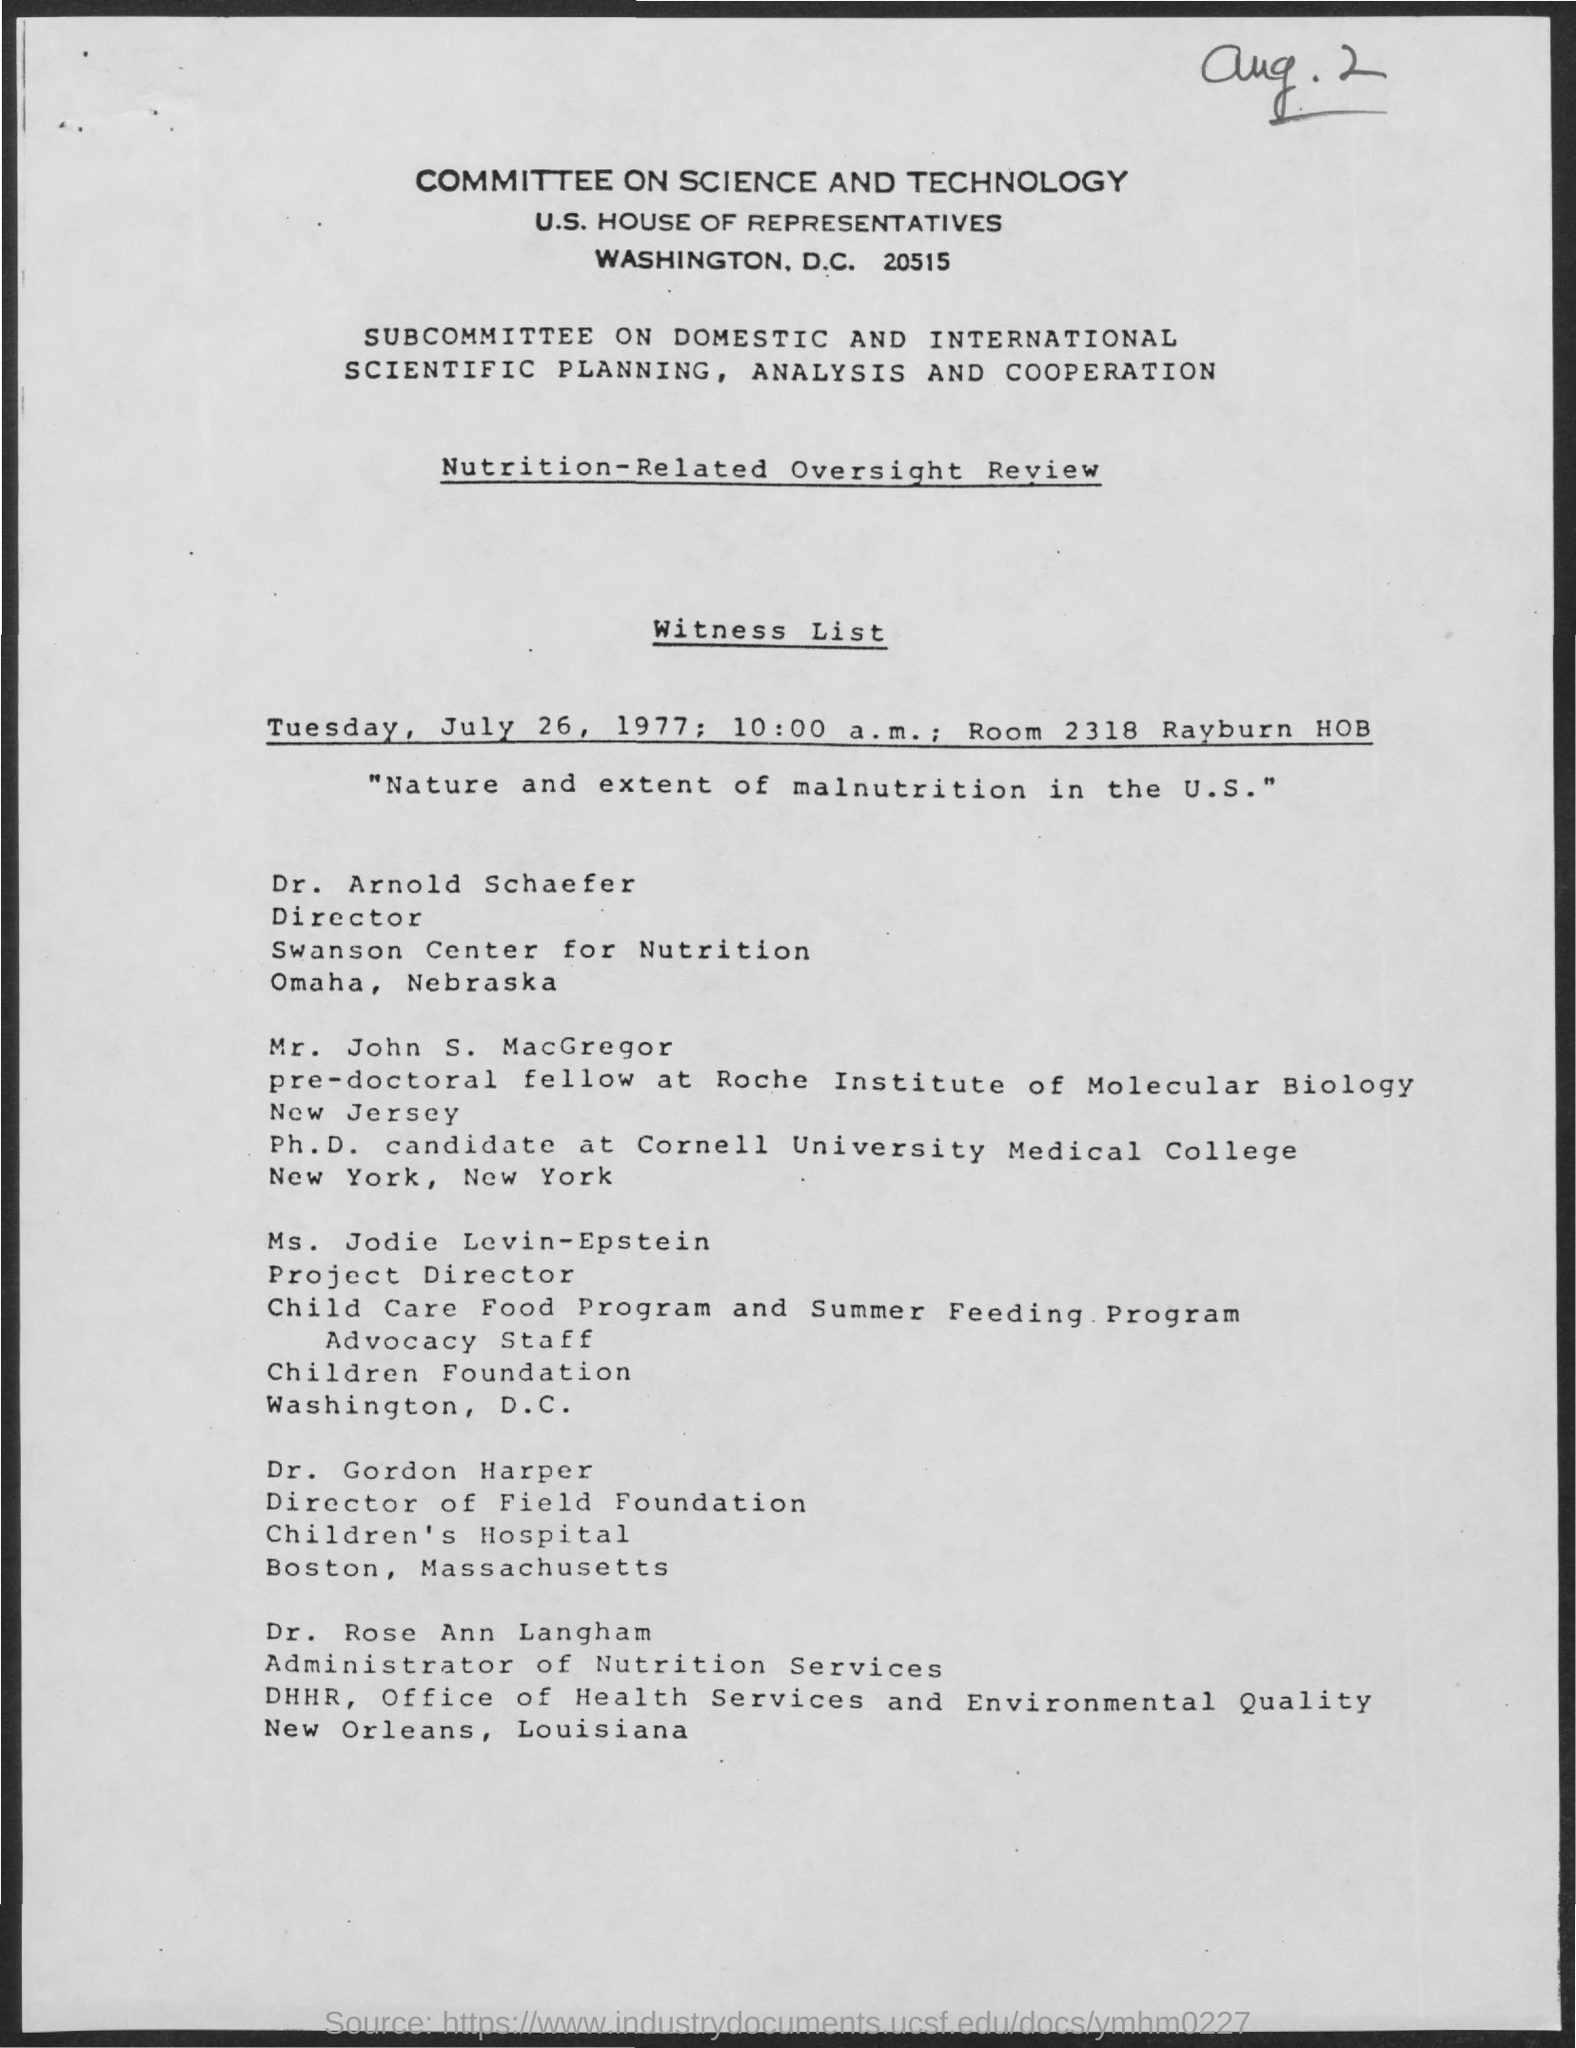What is the title of the document?
Give a very brief answer. Committee on science and technology. What is the room number?
Make the answer very short. 2318. What is the date mentioned in the document?
Provide a succinct answer. Tuesday,July 26, 1977. What is the time mentioned in the document?
Offer a very short reply. 10:00 a.m. 